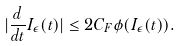Convert formula to latex. <formula><loc_0><loc_0><loc_500><loc_500>| \frac { d } { d t } I _ { \epsilon } ( t ) | \leq 2 C _ { F } \phi ( I _ { \epsilon } ( t ) ) .</formula> 